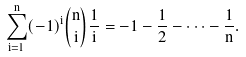Convert formula to latex. <formula><loc_0><loc_0><loc_500><loc_500>\sum _ { i = 1 } ^ { n } ( - 1 ) ^ { i } \binom { n } { i } \frac { 1 } { i } = - 1 - \frac { 1 } { 2 } - \dots - \frac { 1 } { n } .</formula> 